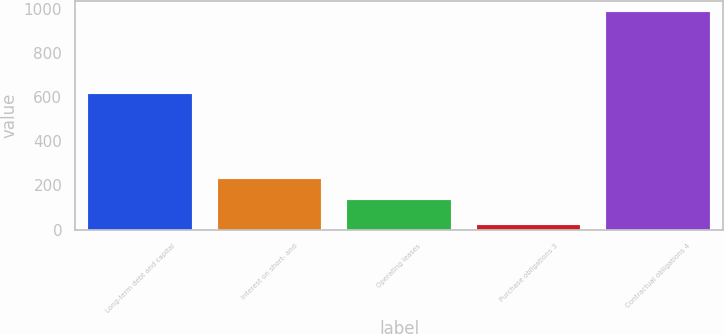Convert chart. <chart><loc_0><loc_0><loc_500><loc_500><bar_chart><fcel>Long-term debt and capital<fcel>Interest on short- and<fcel>Operating leases<fcel>Purchase obligations 3<fcel>Contractual obligations 4<nl><fcel>612<fcel>228.3<fcel>132<fcel>20<fcel>983<nl></chart> 